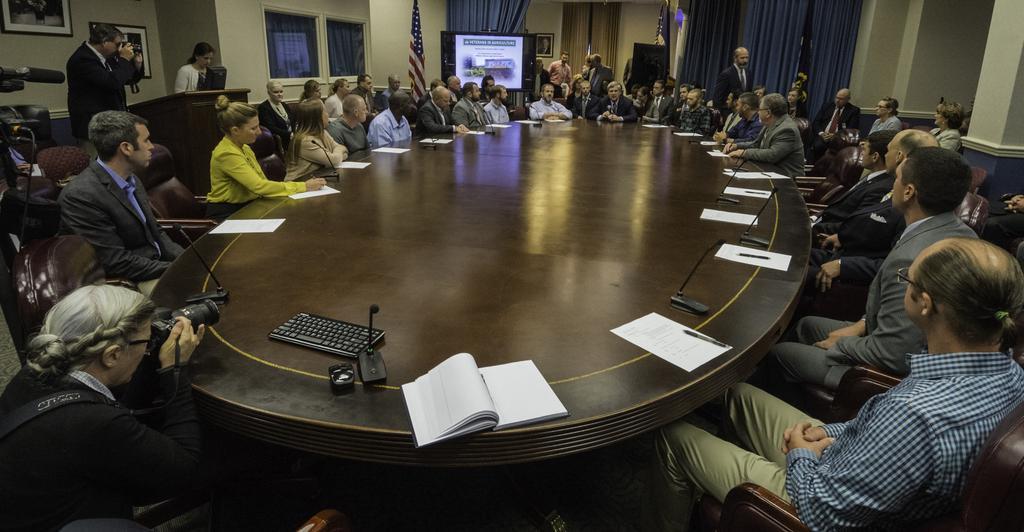Please provide a concise description of this image. Here we can see some persons are sitting on the chairs. This is table. On the table there is a keyboard, mouse, mike's, book, and papers. There is a screen and this is flag. Here we can see two persons are holding a camera with their hands. This is wall and there is a window. On the background there is a curtain. And this is frame. 